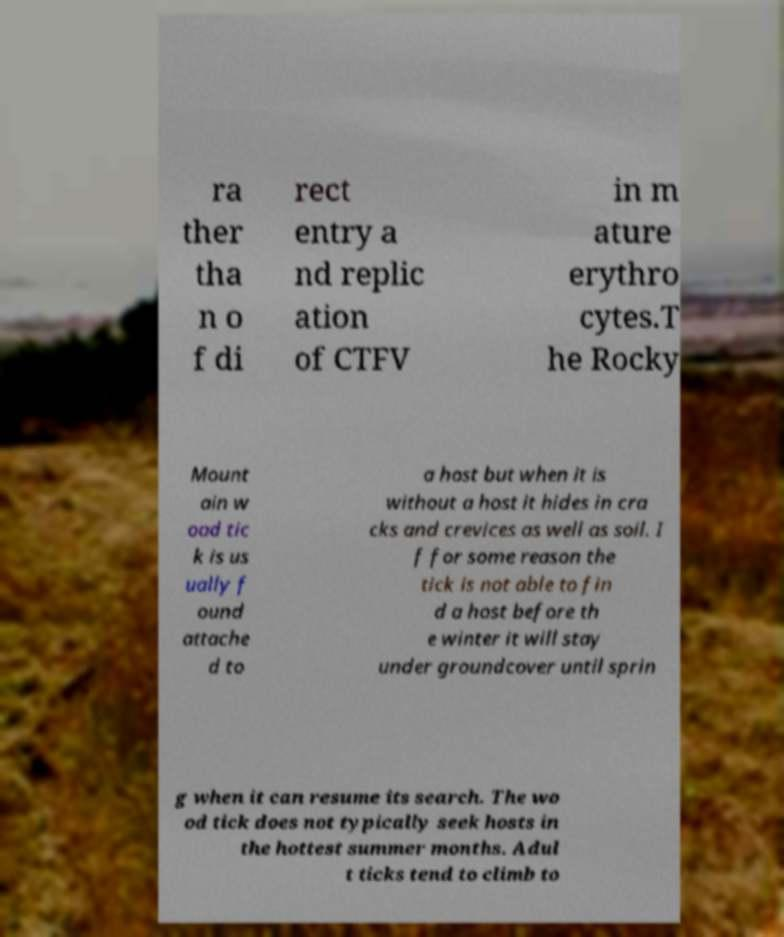Could you assist in decoding the text presented in this image and type it out clearly? ra ther tha n o f di rect entry a nd replic ation of CTFV in m ature erythro cytes.T he Rocky Mount ain w ood tic k is us ually f ound attache d to a host but when it is without a host it hides in cra cks and crevices as well as soil. I f for some reason the tick is not able to fin d a host before th e winter it will stay under groundcover until sprin g when it can resume its search. The wo od tick does not typically seek hosts in the hottest summer months. Adul t ticks tend to climb to 